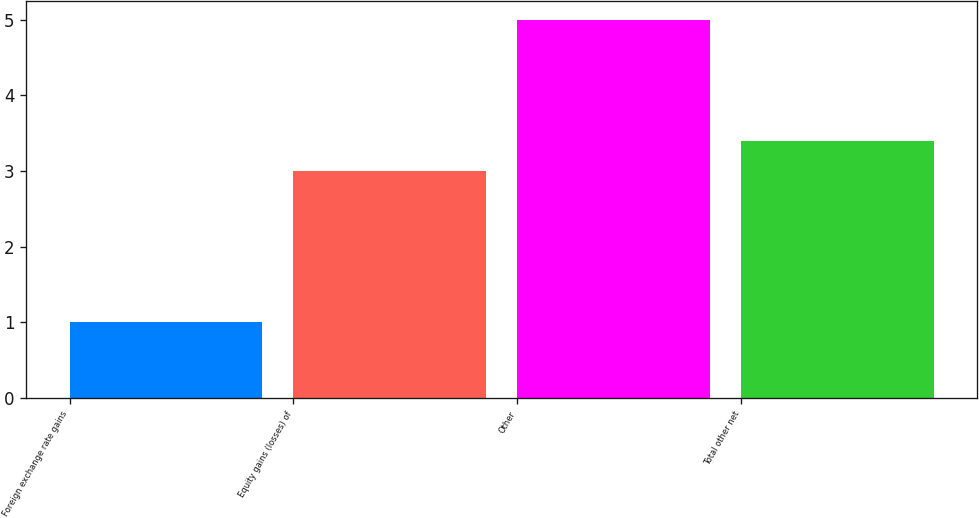Convert chart to OTSL. <chart><loc_0><loc_0><loc_500><loc_500><bar_chart><fcel>Foreign exchange rate gains<fcel>Equity gains (losses) of<fcel>Other<fcel>Total other net<nl><fcel>1<fcel>3<fcel>5<fcel>3.4<nl></chart> 